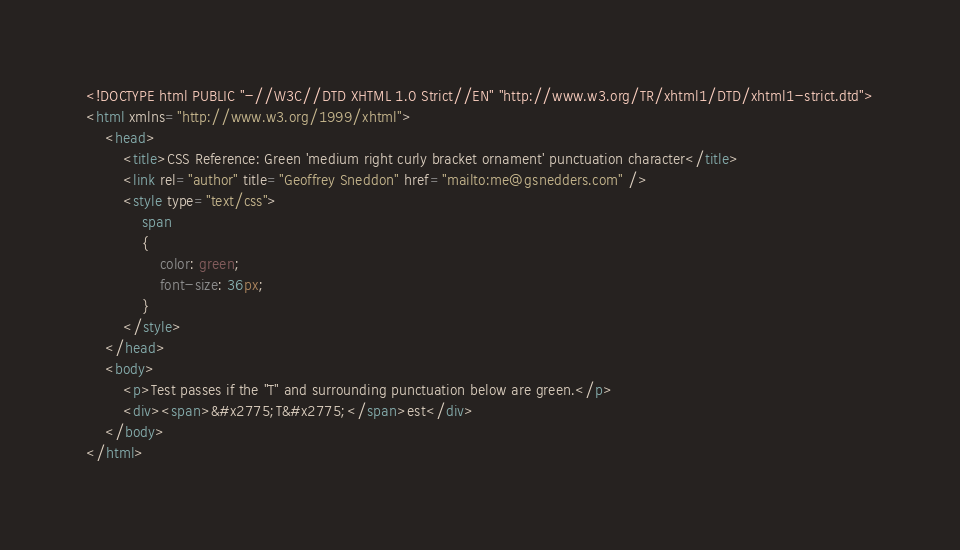Convert code to text. <code><loc_0><loc_0><loc_500><loc_500><_HTML_><!DOCTYPE html PUBLIC "-//W3C//DTD XHTML 1.0 Strict//EN" "http://www.w3.org/TR/xhtml1/DTD/xhtml1-strict.dtd">
<html xmlns="http://www.w3.org/1999/xhtml">
    <head>
        <title>CSS Reference: Green 'medium right curly bracket ornament' punctuation character</title>
        <link rel="author" title="Geoffrey Sneddon" href="mailto:me@gsnedders.com" />
        <style type="text/css">
            span
            {
                color: green;
                font-size: 36px;
            }
        </style>
    </head>
    <body>
        <p>Test passes if the "T" and surrounding punctuation below are green.</p>
        <div><span>&#x2775;T&#x2775;</span>est</div>
    </body>
</html>
</code> 